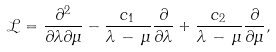<formula> <loc_0><loc_0><loc_500><loc_500>\mathcal { L } = \frac { \partial ^ { 2 } } { \partial \lambda \partial \mu } - \frac { c _ { 1 } } { \lambda \, - \, \mu } \frac { \partial } { \partial \lambda } + \frac { c _ { 2 } } { \lambda \, - \, \mu } \frac { \partial } { \partial \mu } ,</formula> 